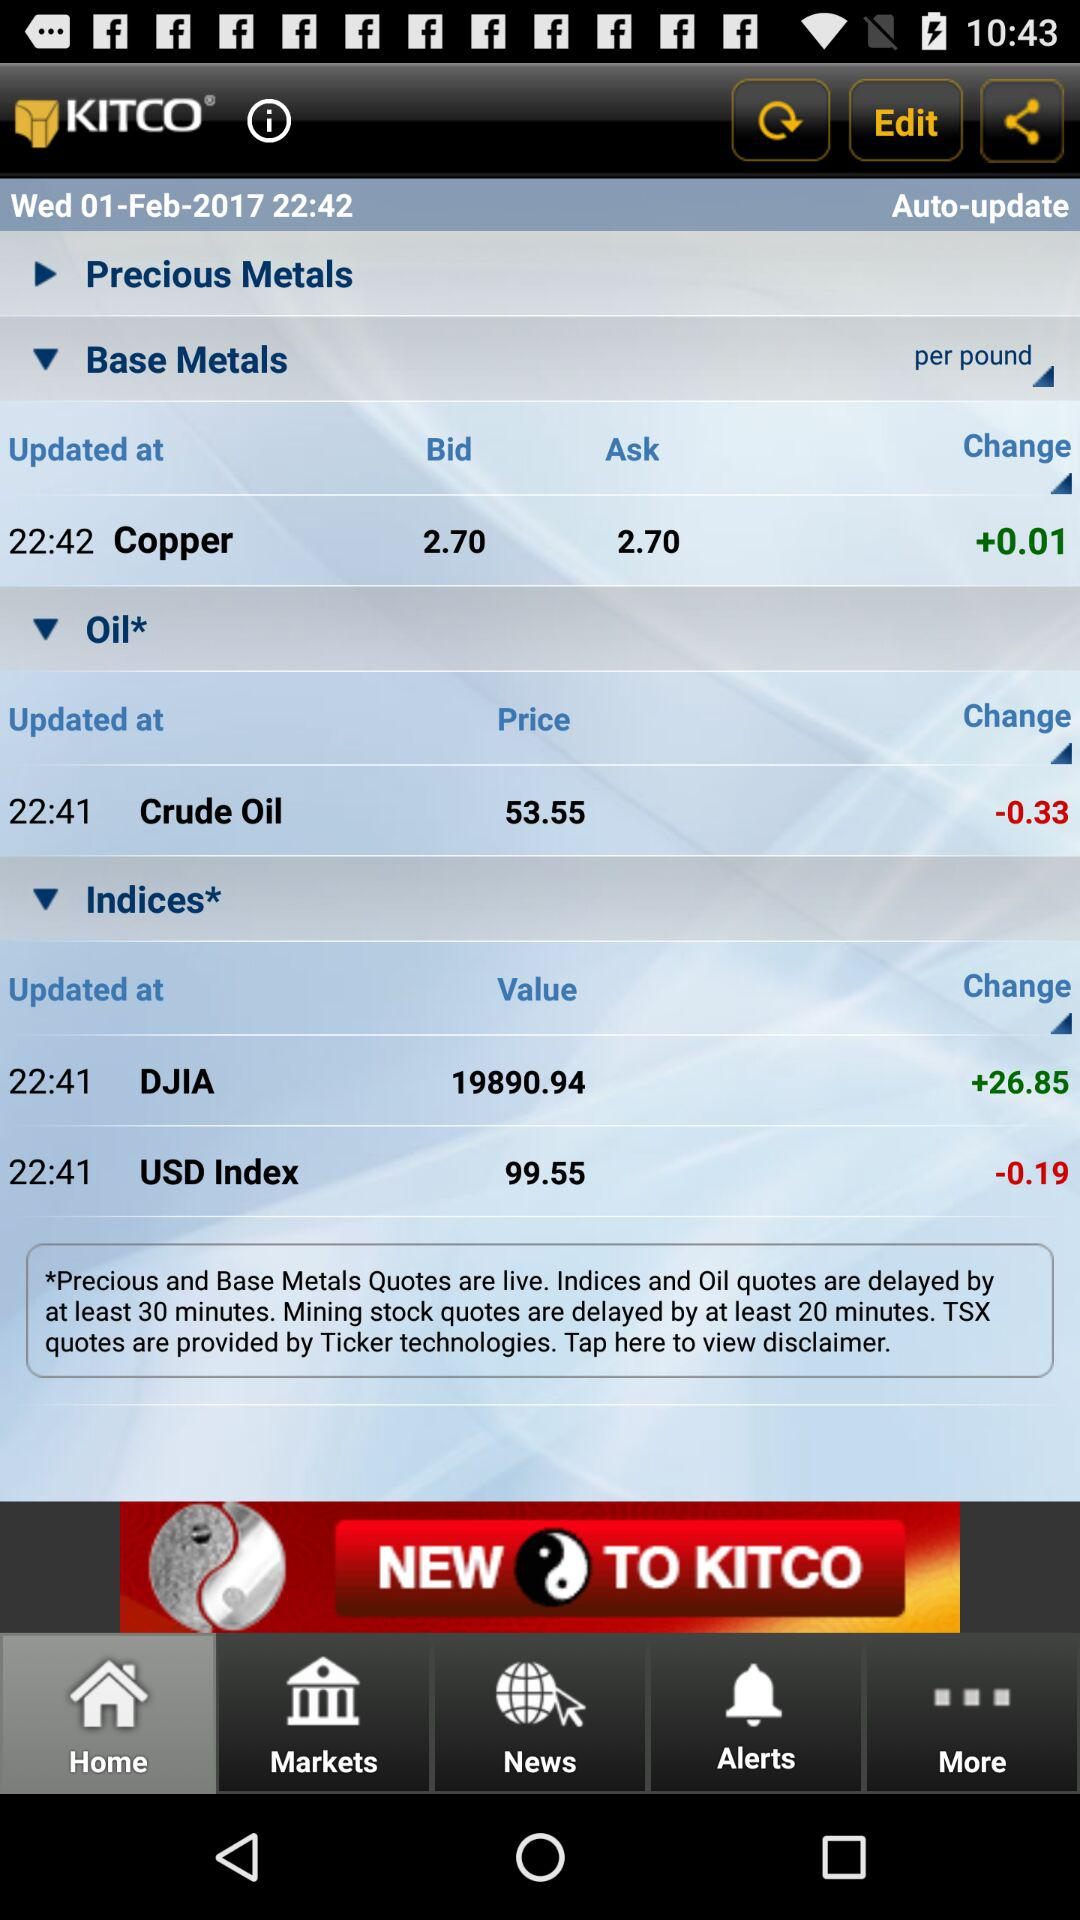Which tab is selected? The selected tab is "Home". 